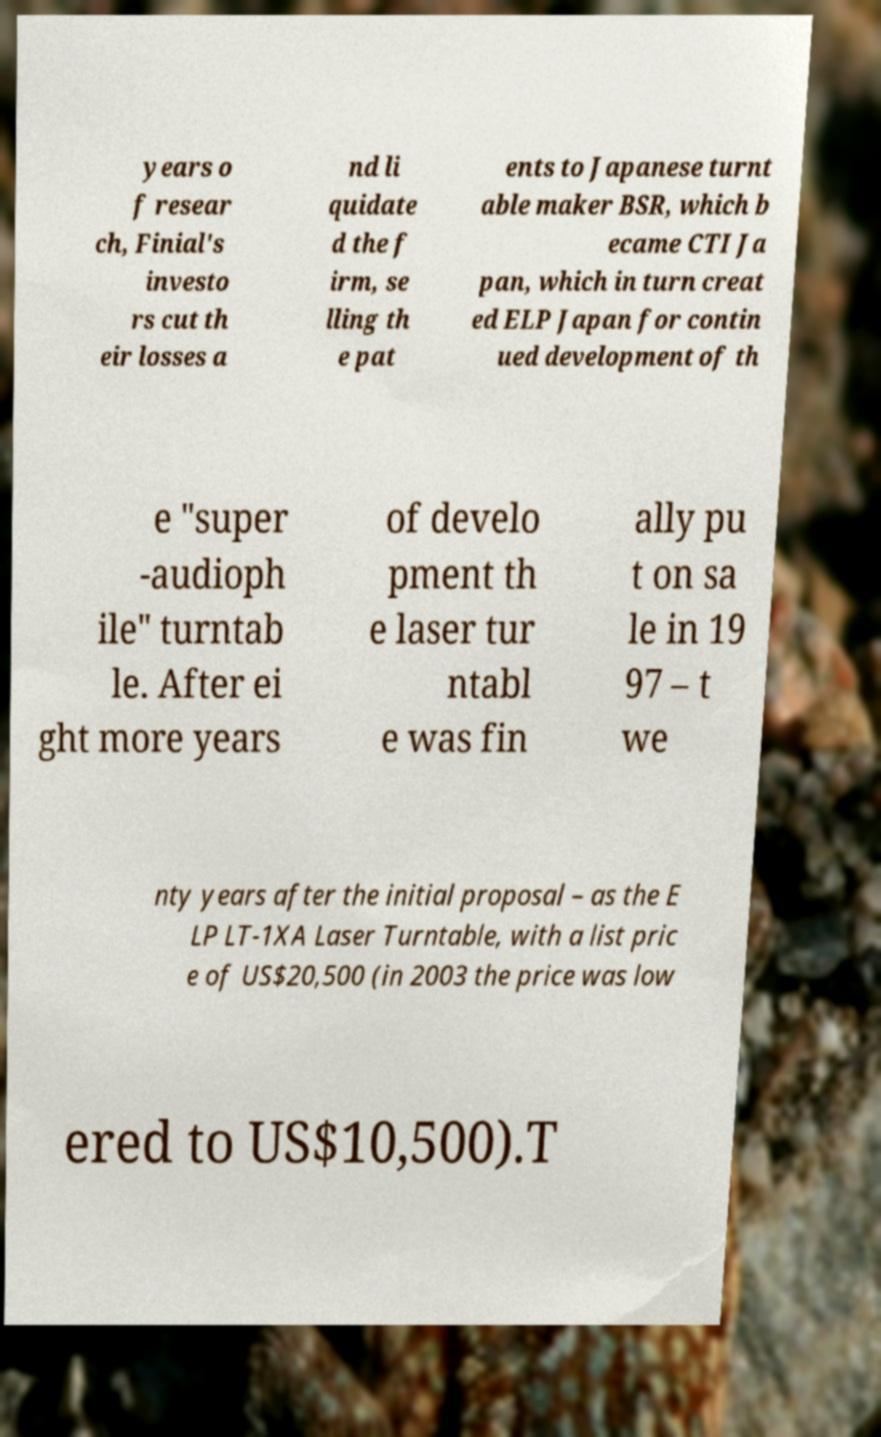For documentation purposes, I need the text within this image transcribed. Could you provide that? years o f resear ch, Finial's investo rs cut th eir losses a nd li quidate d the f irm, se lling th e pat ents to Japanese turnt able maker BSR, which b ecame CTI Ja pan, which in turn creat ed ELP Japan for contin ued development of th e "super -audioph ile" turntab le. After ei ght more years of develo pment th e laser tur ntabl e was fin ally pu t on sa le in 19 97 – t we nty years after the initial proposal – as the E LP LT-1XA Laser Turntable, with a list pric e of US$20,500 (in 2003 the price was low ered to US$10,500).T 